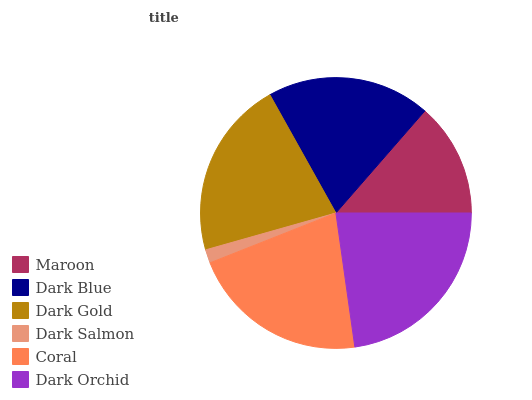Is Dark Salmon the minimum?
Answer yes or no. Yes. Is Dark Orchid the maximum?
Answer yes or no. Yes. Is Dark Blue the minimum?
Answer yes or no. No. Is Dark Blue the maximum?
Answer yes or no. No. Is Dark Blue greater than Maroon?
Answer yes or no. Yes. Is Maroon less than Dark Blue?
Answer yes or no. Yes. Is Maroon greater than Dark Blue?
Answer yes or no. No. Is Dark Blue less than Maroon?
Answer yes or no. No. Is Coral the high median?
Answer yes or no. Yes. Is Dark Blue the low median?
Answer yes or no. Yes. Is Maroon the high median?
Answer yes or no. No. Is Coral the low median?
Answer yes or no. No. 